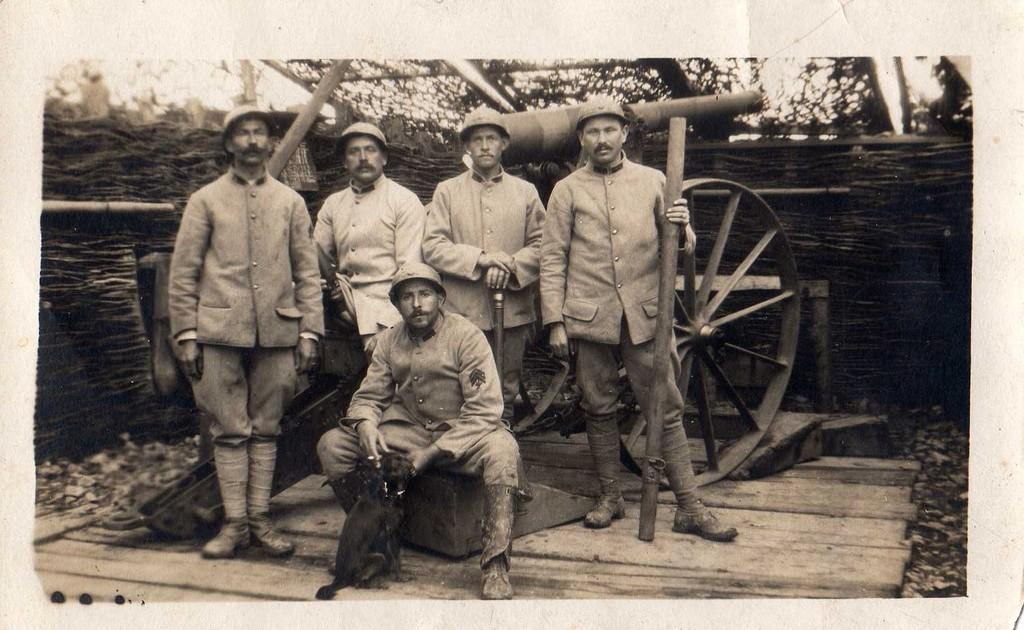What can be seen in the image? There is a group of people and a cart in the image. What is the background of the image? There is a wooden wall in the background of the image. What is the color scheme of the image? The image is in black and white color. What type of income can be seen in the image? There is no reference to income in the image; it features a group of people and a cart in a black and white setting with a wooden wall in the background. 